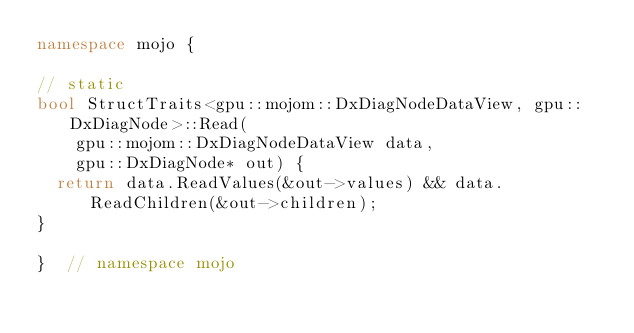Convert code to text. <code><loc_0><loc_0><loc_500><loc_500><_C++_>namespace mojo {

// static
bool StructTraits<gpu::mojom::DxDiagNodeDataView, gpu::DxDiagNode>::Read(
    gpu::mojom::DxDiagNodeDataView data,
    gpu::DxDiagNode* out) {
  return data.ReadValues(&out->values) && data.ReadChildren(&out->children);
}

}  // namespace mojo
</code> 